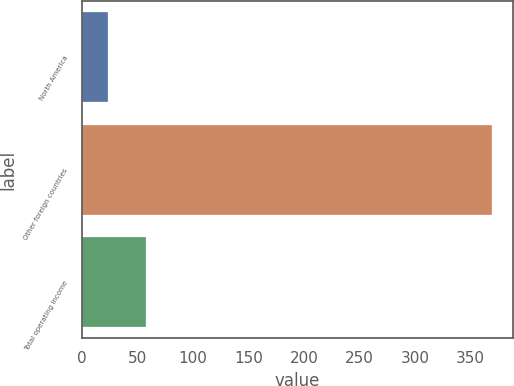Convert chart to OTSL. <chart><loc_0><loc_0><loc_500><loc_500><bar_chart><fcel>North America<fcel>Other foreign countries<fcel>Total operating income<nl><fcel>23.5<fcel>369.5<fcel>58.1<nl></chart> 